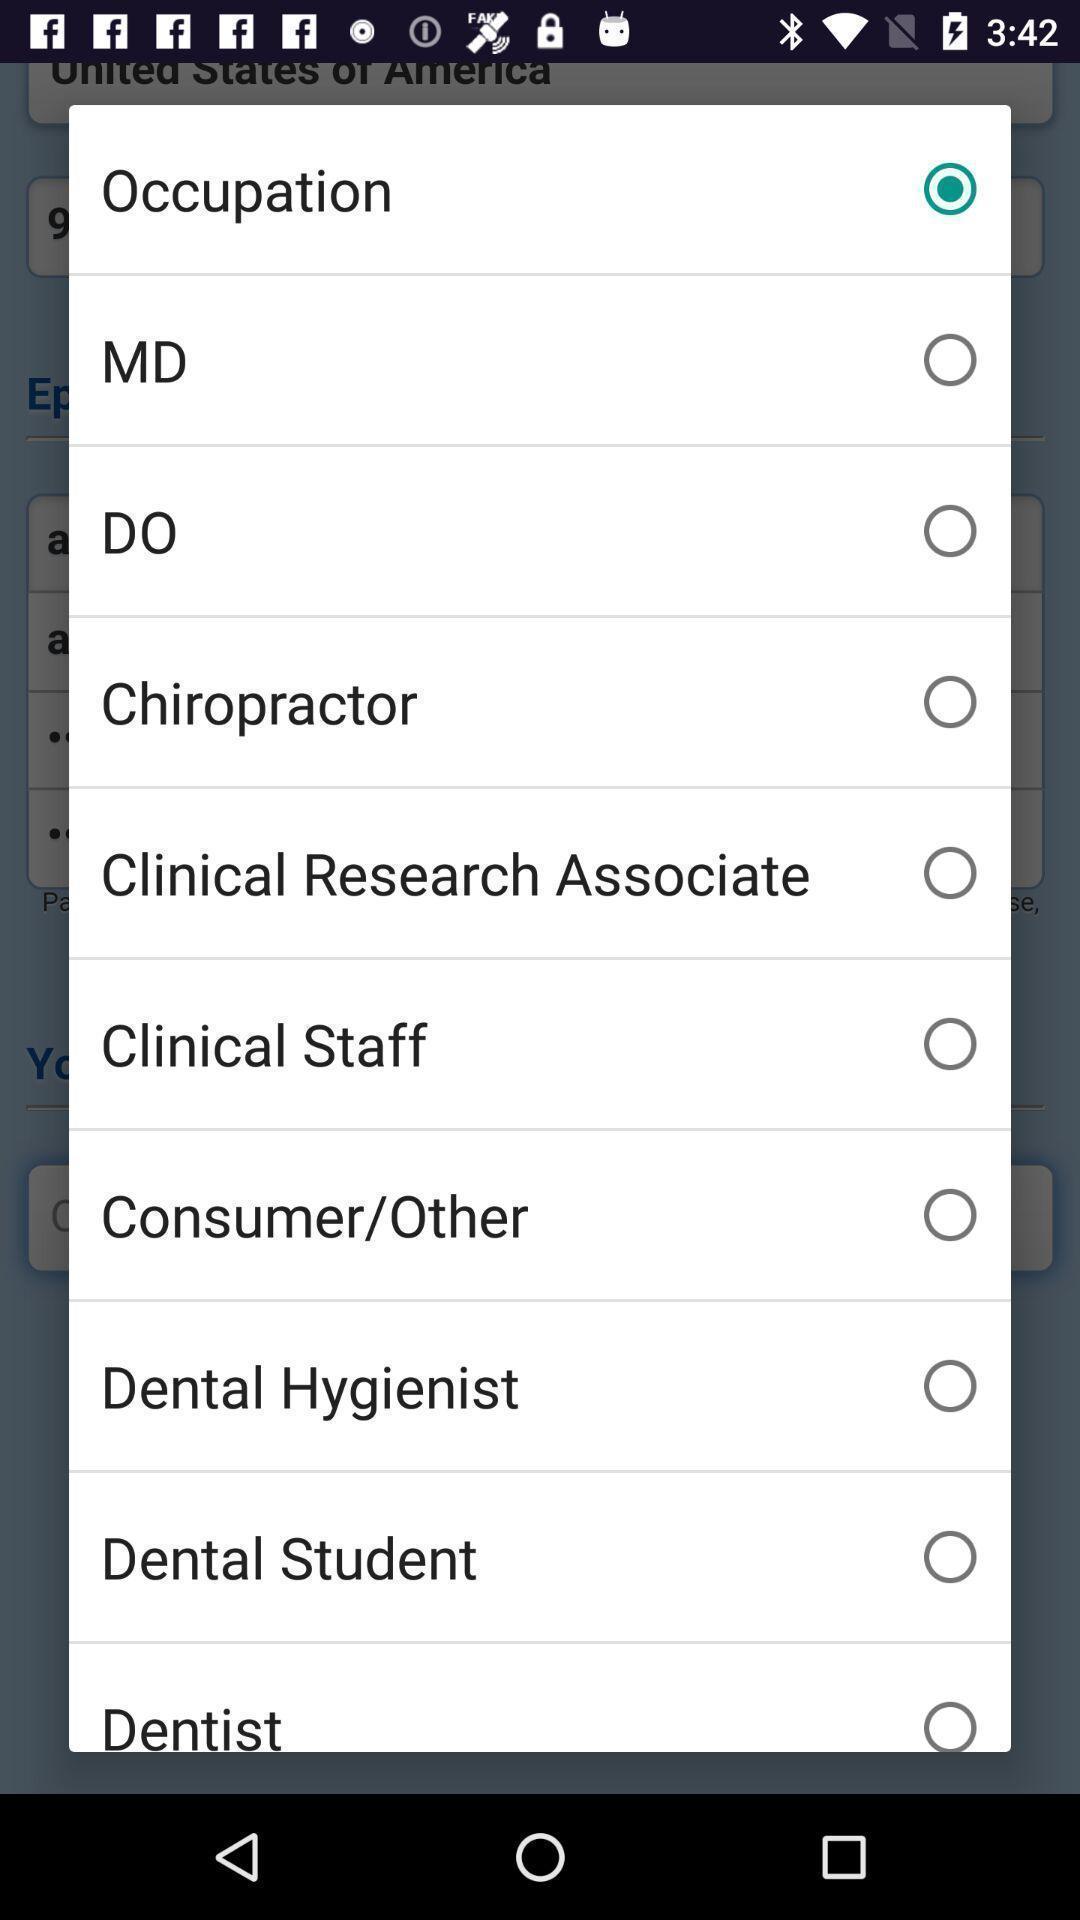Please provide a description for this image. Pop-up showing list of information. 